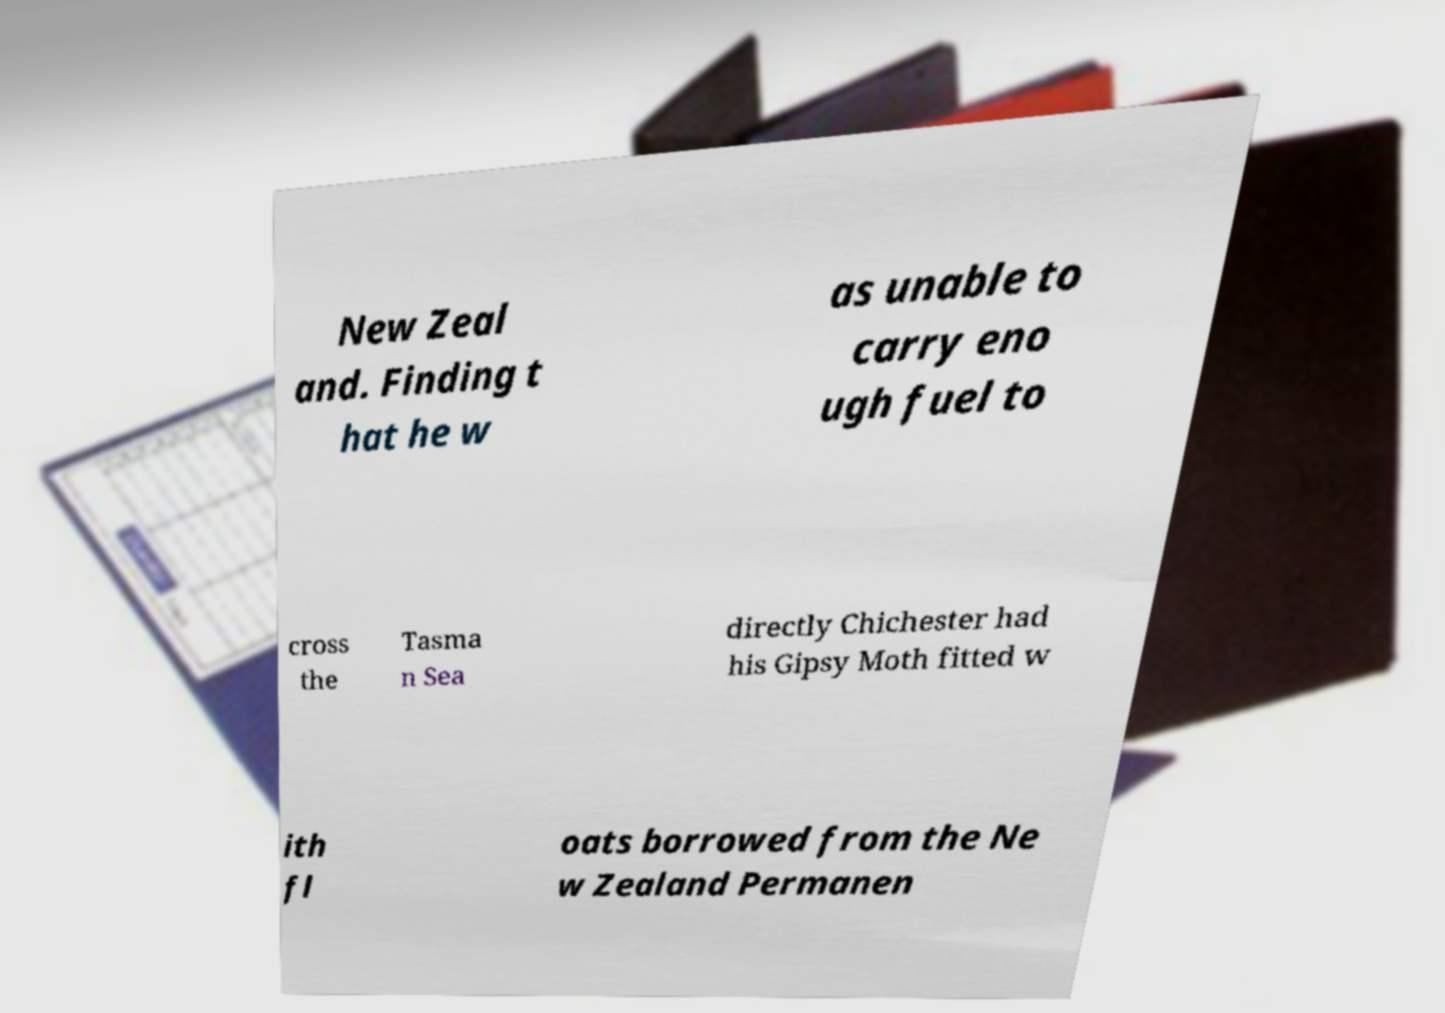There's text embedded in this image that I need extracted. Can you transcribe it verbatim? New Zeal and. Finding t hat he w as unable to carry eno ugh fuel to cross the Tasma n Sea directly Chichester had his Gipsy Moth fitted w ith fl oats borrowed from the Ne w Zealand Permanen 